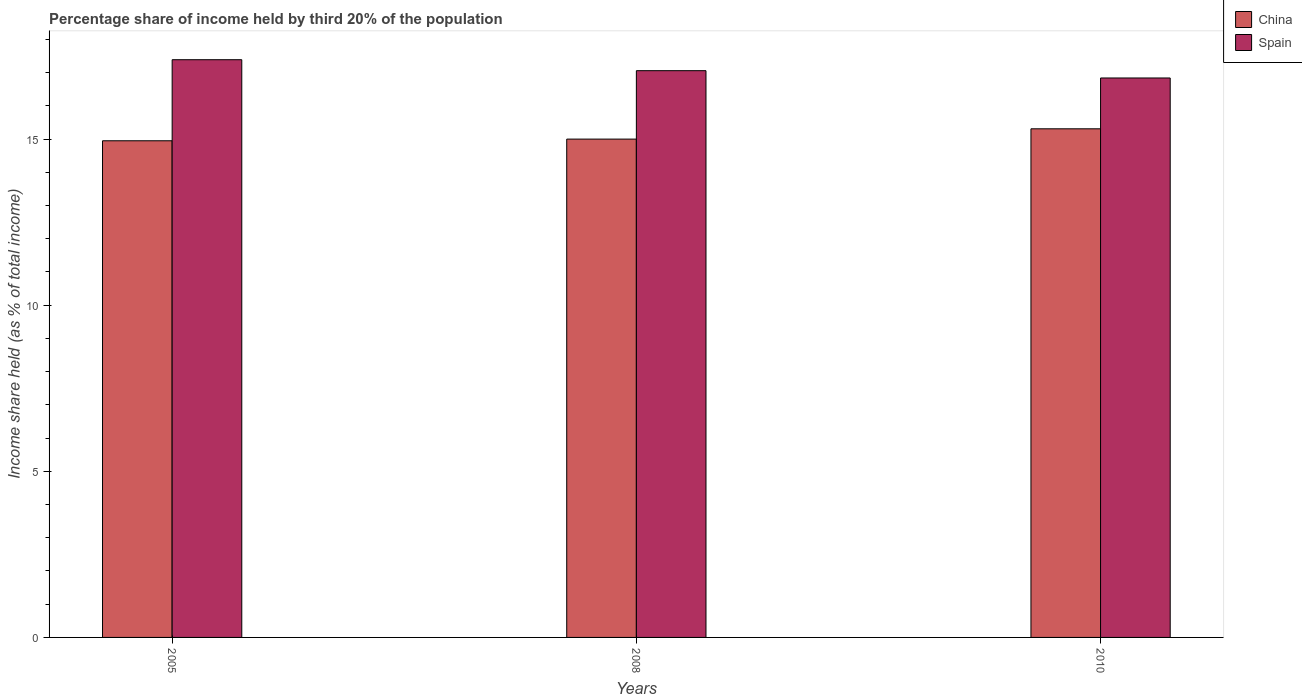Are the number of bars per tick equal to the number of legend labels?
Provide a short and direct response. Yes. Are the number of bars on each tick of the X-axis equal?
Your answer should be compact. Yes. How many bars are there on the 2nd tick from the left?
Provide a short and direct response. 2. What is the label of the 3rd group of bars from the left?
Ensure brevity in your answer.  2010. In how many cases, is the number of bars for a given year not equal to the number of legend labels?
Offer a very short reply. 0. What is the share of income held by third 20% of the population in Spain in 2008?
Keep it short and to the point. 17.06. Across all years, what is the maximum share of income held by third 20% of the population in China?
Offer a very short reply. 15.31. Across all years, what is the minimum share of income held by third 20% of the population in Spain?
Your response must be concise. 16.84. What is the total share of income held by third 20% of the population in Spain in the graph?
Offer a very short reply. 51.29. What is the difference between the share of income held by third 20% of the population in Spain in 2008 and that in 2010?
Make the answer very short. 0.22. What is the difference between the share of income held by third 20% of the population in China in 2008 and the share of income held by third 20% of the population in Spain in 2005?
Keep it short and to the point. -2.39. What is the average share of income held by third 20% of the population in Spain per year?
Provide a succinct answer. 17.1. In the year 2008, what is the difference between the share of income held by third 20% of the population in Spain and share of income held by third 20% of the population in China?
Give a very brief answer. 2.06. What is the ratio of the share of income held by third 20% of the population in China in 2005 to that in 2010?
Offer a terse response. 0.98. Is the difference between the share of income held by third 20% of the population in Spain in 2008 and 2010 greater than the difference between the share of income held by third 20% of the population in China in 2008 and 2010?
Provide a succinct answer. Yes. What is the difference between the highest and the second highest share of income held by third 20% of the population in China?
Offer a terse response. 0.31. What is the difference between the highest and the lowest share of income held by third 20% of the population in Spain?
Keep it short and to the point. 0.55. Are all the bars in the graph horizontal?
Provide a succinct answer. No. How many years are there in the graph?
Give a very brief answer. 3. Does the graph contain any zero values?
Offer a very short reply. No. Where does the legend appear in the graph?
Your answer should be very brief. Top right. What is the title of the graph?
Offer a terse response. Percentage share of income held by third 20% of the population. What is the label or title of the Y-axis?
Provide a succinct answer. Income share held (as % of total income). What is the Income share held (as % of total income) of China in 2005?
Provide a short and direct response. 14.95. What is the Income share held (as % of total income) of Spain in 2005?
Your response must be concise. 17.39. What is the Income share held (as % of total income) in China in 2008?
Provide a succinct answer. 15. What is the Income share held (as % of total income) of Spain in 2008?
Make the answer very short. 17.06. What is the Income share held (as % of total income) in China in 2010?
Provide a succinct answer. 15.31. What is the Income share held (as % of total income) of Spain in 2010?
Make the answer very short. 16.84. Across all years, what is the maximum Income share held (as % of total income) in China?
Your response must be concise. 15.31. Across all years, what is the maximum Income share held (as % of total income) of Spain?
Your response must be concise. 17.39. Across all years, what is the minimum Income share held (as % of total income) in China?
Give a very brief answer. 14.95. Across all years, what is the minimum Income share held (as % of total income) in Spain?
Your answer should be very brief. 16.84. What is the total Income share held (as % of total income) of China in the graph?
Your answer should be very brief. 45.26. What is the total Income share held (as % of total income) in Spain in the graph?
Provide a short and direct response. 51.29. What is the difference between the Income share held (as % of total income) in China in 2005 and that in 2008?
Ensure brevity in your answer.  -0.05. What is the difference between the Income share held (as % of total income) in Spain in 2005 and that in 2008?
Keep it short and to the point. 0.33. What is the difference between the Income share held (as % of total income) in China in 2005 and that in 2010?
Keep it short and to the point. -0.36. What is the difference between the Income share held (as % of total income) in Spain in 2005 and that in 2010?
Make the answer very short. 0.55. What is the difference between the Income share held (as % of total income) of China in 2008 and that in 2010?
Provide a succinct answer. -0.31. What is the difference between the Income share held (as % of total income) of Spain in 2008 and that in 2010?
Offer a very short reply. 0.22. What is the difference between the Income share held (as % of total income) of China in 2005 and the Income share held (as % of total income) of Spain in 2008?
Offer a very short reply. -2.11. What is the difference between the Income share held (as % of total income) of China in 2005 and the Income share held (as % of total income) of Spain in 2010?
Ensure brevity in your answer.  -1.89. What is the difference between the Income share held (as % of total income) of China in 2008 and the Income share held (as % of total income) of Spain in 2010?
Provide a succinct answer. -1.84. What is the average Income share held (as % of total income) in China per year?
Your answer should be compact. 15.09. What is the average Income share held (as % of total income) of Spain per year?
Ensure brevity in your answer.  17.1. In the year 2005, what is the difference between the Income share held (as % of total income) of China and Income share held (as % of total income) of Spain?
Your answer should be compact. -2.44. In the year 2008, what is the difference between the Income share held (as % of total income) in China and Income share held (as % of total income) in Spain?
Keep it short and to the point. -2.06. In the year 2010, what is the difference between the Income share held (as % of total income) in China and Income share held (as % of total income) in Spain?
Your response must be concise. -1.53. What is the ratio of the Income share held (as % of total income) of Spain in 2005 to that in 2008?
Your answer should be compact. 1.02. What is the ratio of the Income share held (as % of total income) of China in 2005 to that in 2010?
Keep it short and to the point. 0.98. What is the ratio of the Income share held (as % of total income) of Spain in 2005 to that in 2010?
Ensure brevity in your answer.  1.03. What is the ratio of the Income share held (as % of total income) of China in 2008 to that in 2010?
Your answer should be very brief. 0.98. What is the ratio of the Income share held (as % of total income) of Spain in 2008 to that in 2010?
Offer a terse response. 1.01. What is the difference between the highest and the second highest Income share held (as % of total income) in China?
Your response must be concise. 0.31. What is the difference between the highest and the second highest Income share held (as % of total income) of Spain?
Offer a very short reply. 0.33. What is the difference between the highest and the lowest Income share held (as % of total income) in China?
Your response must be concise. 0.36. What is the difference between the highest and the lowest Income share held (as % of total income) of Spain?
Offer a very short reply. 0.55. 